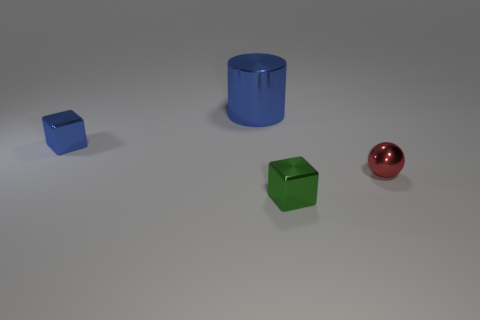What is the color of the sphere that is on the right side of the small shiny cube that is on the left side of the green shiny thing? red 